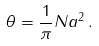<formula> <loc_0><loc_0><loc_500><loc_500>\theta = \frac { 1 } { \pi } N a ^ { 2 } \, .</formula> 